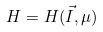<formula> <loc_0><loc_0><loc_500><loc_500>H = H ( \vec { I } , \mu )</formula> 